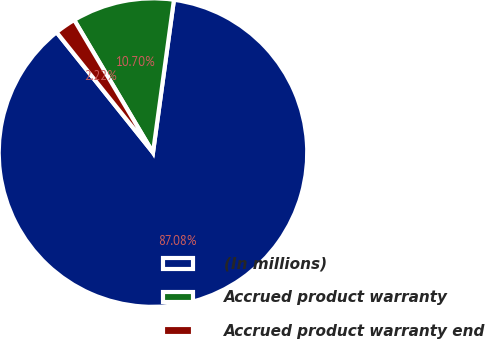Convert chart to OTSL. <chart><loc_0><loc_0><loc_500><loc_500><pie_chart><fcel>(In millions)<fcel>Accrued product warranty<fcel>Accrued product warranty end<nl><fcel>87.08%<fcel>10.7%<fcel>2.22%<nl></chart> 